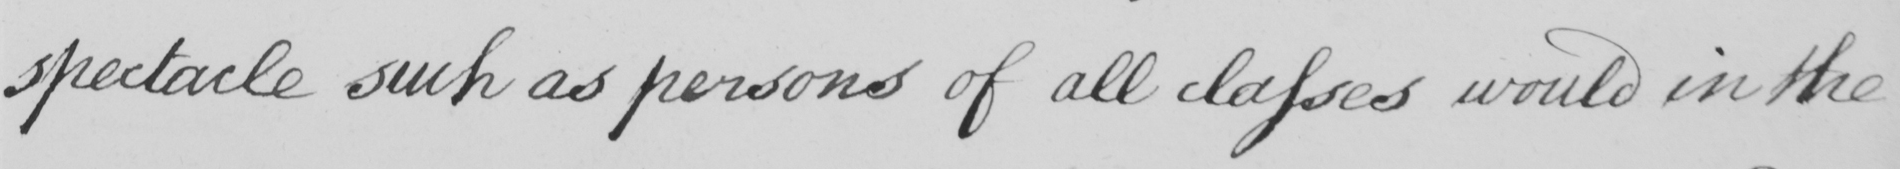What does this handwritten line say? spectacle such as persons of all classes would in the 